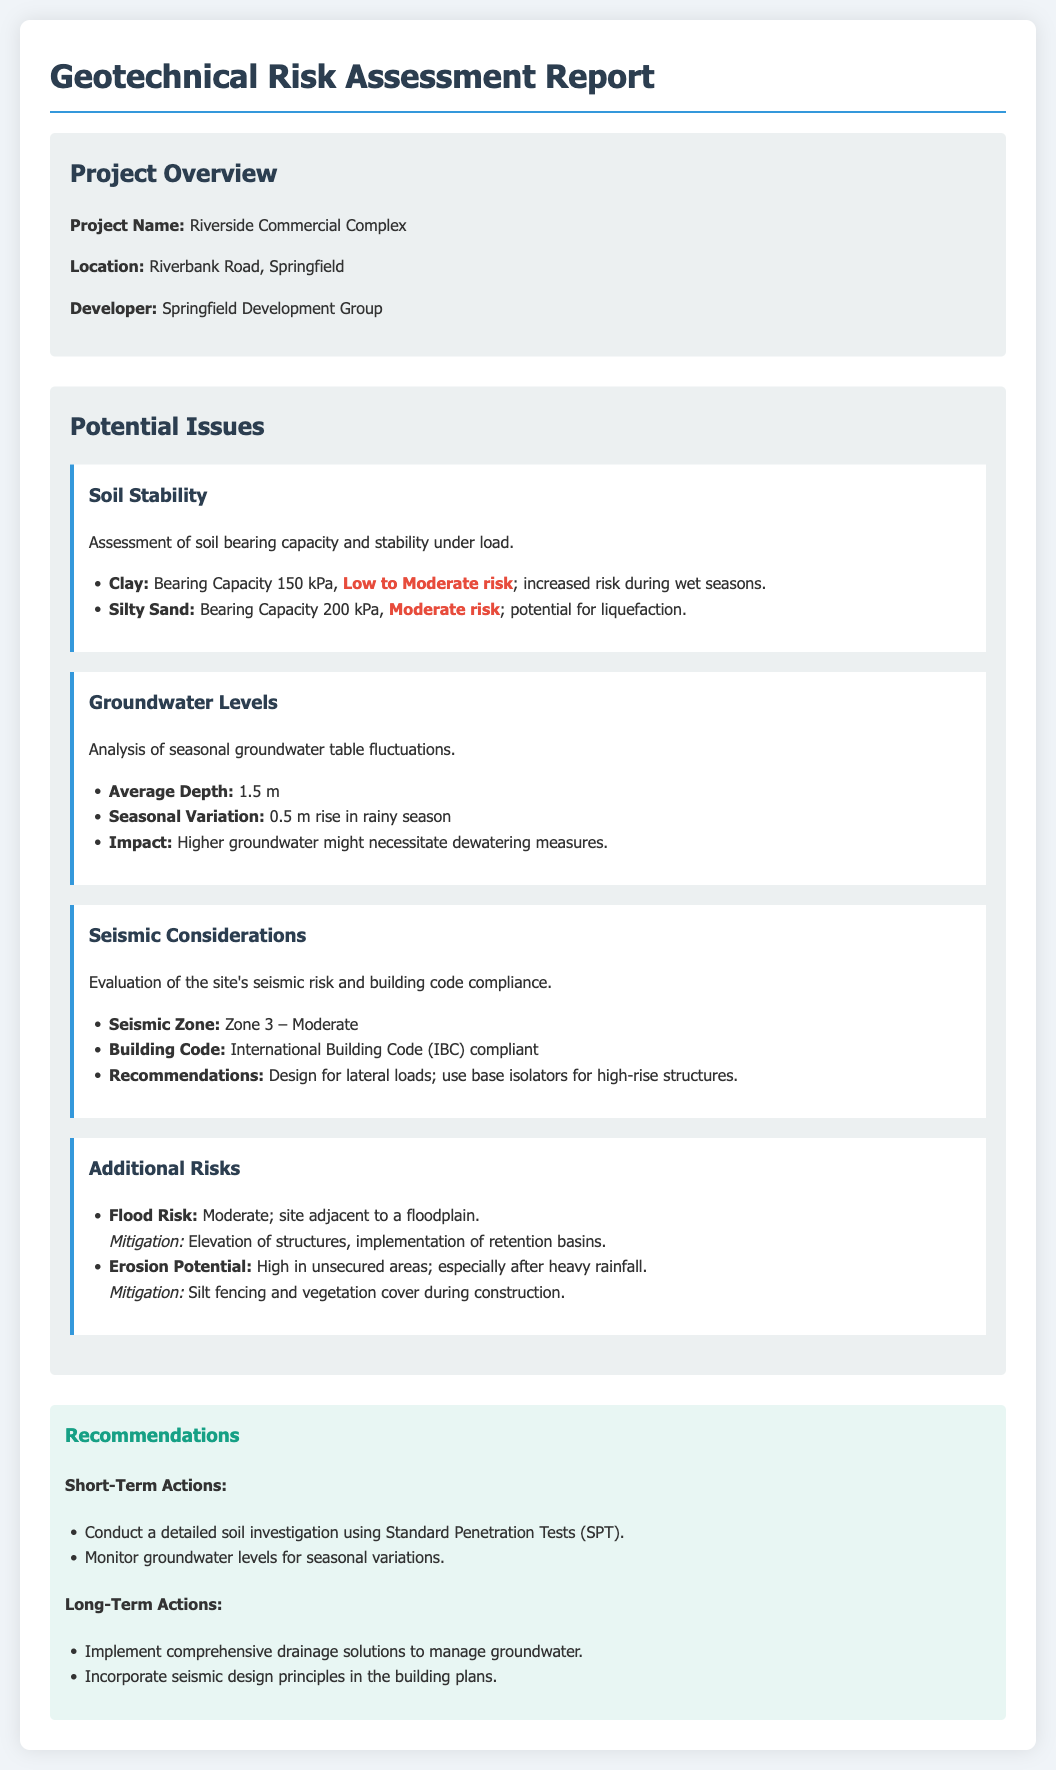What is the project name? The project name is specified in the project overview section of the document.
Answer: Riverside Commercial Complex What is the average groundwater depth? The average depth of groundwater is listed under the groundwater levels section.
Answer: 1.5 m What is the seismic zone of the site? The seismic zone is mentioned in the seismic considerations section of the document.
Answer: Zone 3 – Moderate What is the bearing capacity of silty sand? The bearing capacity for silty sand is provided in the soil stability assessment.
Answer: 200 kPa What short-term action is recommended? The document lists specific short-term actions in the recommendations section.
Answer: Conduct a detailed soil investigation using Standard Penetration Tests (SPT) What is the flood risk described in the document? The flood risk assessment is detailed under additional risks in the document.
Answer: Moderate What should be monitored for seasonal variations? The recommendations section includes specific items to monitor for seasonal changes.
Answer: Groundwater levels What is a suggested long-term action in the document? Long-term actions are highlighted in the recommendations section, indicating comprehensive solutions.
Answer: Implement comprehensive drainage solutions to manage groundwater What is the impact of higher groundwater levels? The document explains the potential impacts of groundwater levels under the groundwater section.
Answer: Higher groundwater might necessitate dewatering measures 